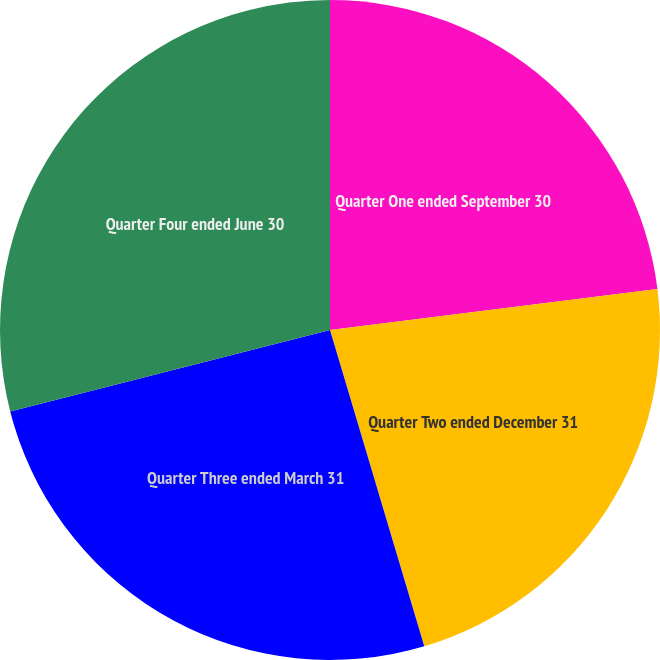Convert chart to OTSL. <chart><loc_0><loc_0><loc_500><loc_500><pie_chart><fcel>Quarter One ended September 30<fcel>Quarter Two ended December 31<fcel>Quarter Three ended March 31<fcel>Quarter Four ended June 30<nl><fcel>23.02%<fcel>22.37%<fcel>25.64%<fcel>28.97%<nl></chart> 